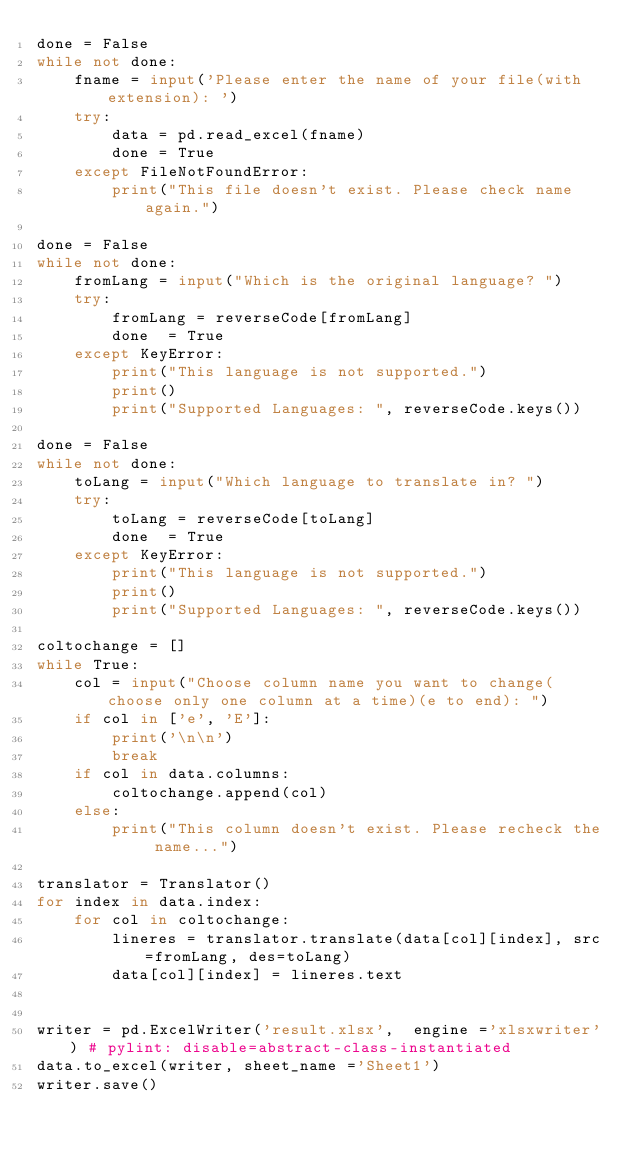Convert code to text. <code><loc_0><loc_0><loc_500><loc_500><_Python_>done = False
while not done:
    fname = input('Please enter the name of your file(with extension): ')
    try:
        data = pd.read_excel(fname)
        done = True
    except FileNotFoundError:
        print("This file doesn't exist. Please check name again.")
               
done = False
while not done:
    fromLang = input("Which is the original language? ")
    try:
        fromLang = reverseCode[fromLang]
        done  = True
    except KeyError:
        print("This language is not supported.")
        print()
        print("Supported Languages: ", reverseCode.keys())
            
done = False
while not done:
    toLang = input("Which language to translate in? ")
    try:
        toLang = reverseCode[toLang]
        done  = True
    except KeyError:
        print("This language is not supported.")
        print()
        print("Supported Languages: ", reverseCode.keys())
    
coltochange = []
while True:
    col = input("Choose column name you want to change(choose only one column at a time)(e to end): ")
    if col in ['e', 'E']:
        print('\n\n') 
        break
    if col in data.columns:
        coltochange.append(col)
    else:
        print("This column doesn't exist. Please recheck the name...")

translator = Translator()
for index in data.index:
    for col in coltochange:
        lineres = translator.translate(data[col][index], src=fromLang, des=toLang)
        data[col][index] = lineres.text
        
    
writer = pd.ExcelWriter('result.xlsx',  engine ='xlsxwriter') # pylint: disable=abstract-class-instantiated
data.to_excel(writer, sheet_name ='Sheet1') 
writer.save() 
</code> 